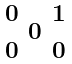Convert formula to latex. <formula><loc_0><loc_0><loc_500><loc_500>\begin{smallmatrix} 0 & & 1 \\ & 0 & \\ 0 & & 0 \end{smallmatrix}</formula> 